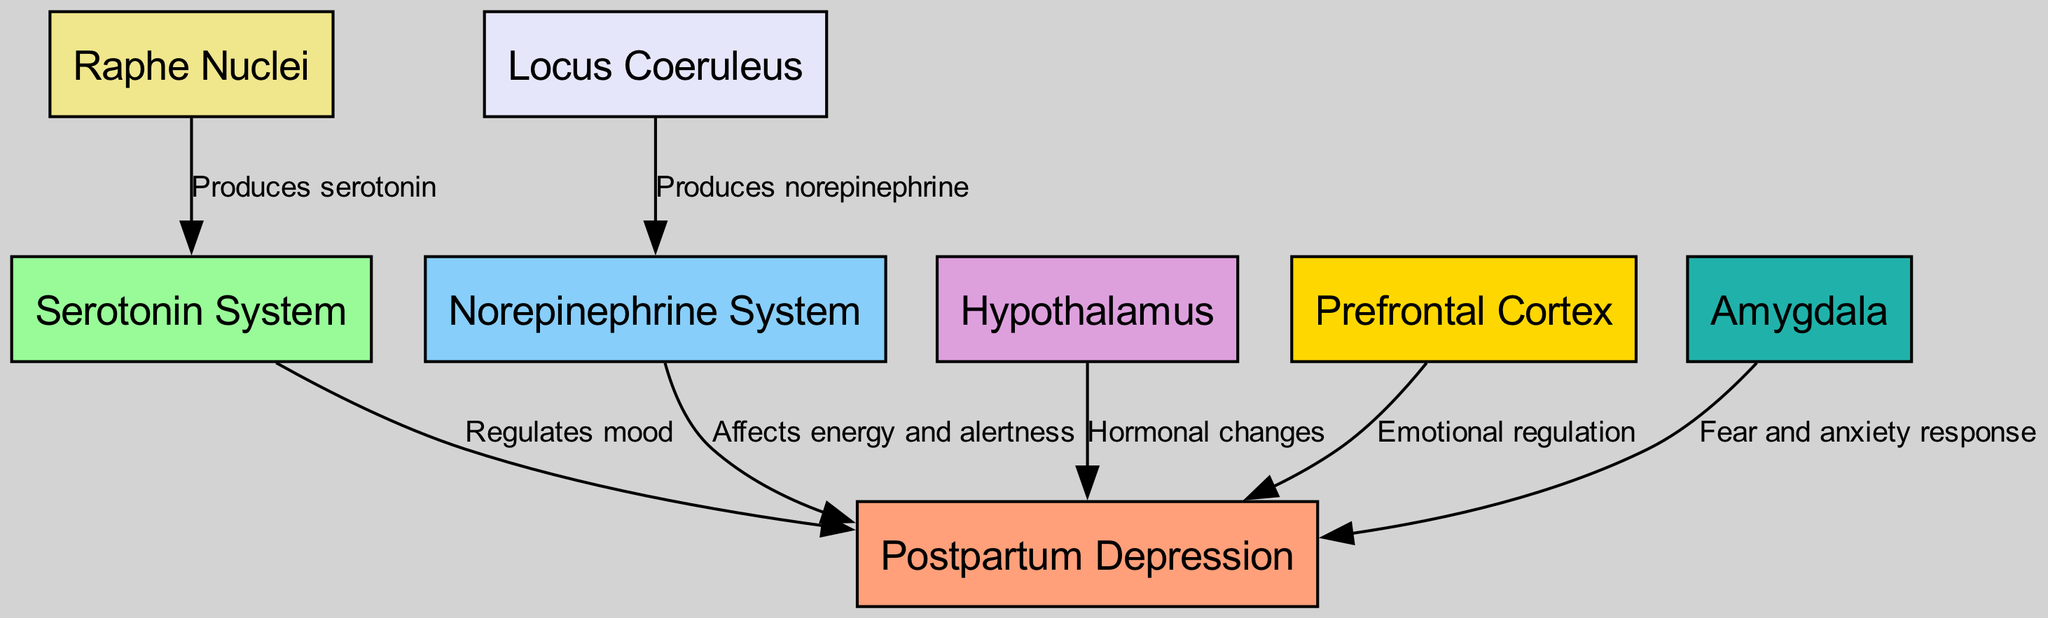What is the main disorder represented in the diagram? The diagram identifies "Postpartum Depression" as the main disorder, shown as the central node connected to various pathways.
Answer: Postpartum Depression How many nodes are present in the diagram? By counting the distinct labels in the diagram, there are a total of eight nodes listed under "nodes."
Answer: 8 Which system produces serotonin? Referring to the edges linked to the nodes, the "Raphe Nuclei" node is indicated to produce serotonin, as shown by the directed edge labeled "Produces serotonin."
Answer: Raphe Nuclei What role does the prefrontal cortex play in postpartum depression? The diagram connects the "Prefrontal Cortex" node to "Postpartum Depression" with the label "Emotional regulation," indicating its role in managing emotional responses.
Answer: Emotional regulation Which brain region is linked to fear and anxiety responses? The diagram explicitly connects the "Amygdala" to "Postpartum Depression" with the edge labeled "Fear and anxiety response," showing its involvement in these emotional processes.
Answer: Amygdala What are the two neurotransmitter systems involved in the diagram? The nodes labeled "Serotonin System" and "Norepinephrine System" represent the two neurotransmitter systems included in the diagram, linked to the primary disorder.
Answer: Serotonin System and Norepinephrine System How does hormonal changes affect postpartum depression? The "Hypothalamus" node is linked to "Postpartum Depression" with the edge labeled "Hormonal changes," indicating that hormonal fluctuations contribute to the disorder.
Answer: Hormonal changes How does norepinephrine affect postpartum depression? The Norepinephrine System node is connected to "Postpartum Depression" with the label "Affects energy and alertness," which explains its impact on the disorder.
Answer: Affects energy and alertness What is the connection between the locus coeruleus and postpartum depression? The edge labeled "Produces norepinephrine" links "Locus Coeruleus" with "Norepinephrine System," indicating its role in producing a neurotransmitter that influences postpartum depression.
Answer: Produces norepinephrine 